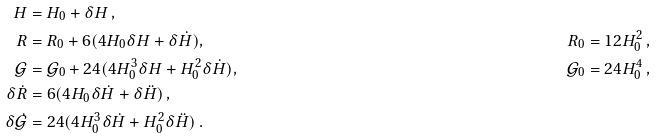Convert formula to latex. <formula><loc_0><loc_0><loc_500><loc_500>H & = H _ { 0 } + \delta H \, , & \\ R & = R _ { 0 } + 6 ( 4 H _ { 0 } \delta H + \delta \dot { H } ) , & R _ { 0 } = 1 2 H _ { 0 } ^ { 2 } \, , \\ \mathcal { G } & = \mathcal { G } _ { 0 } + 2 4 ( 4 H _ { 0 } ^ { 3 } \delta H + H _ { 0 } ^ { 2 } \delta \dot { H } ) , & \mathcal { G } _ { 0 } = 2 4 H _ { 0 } ^ { 4 } \, , \\ \delta \dot { R } & = 6 ( 4 H _ { 0 } \delta \dot { H } + \delta \ddot { H } ) \, , & \\ \delta \dot { \mathcal { G } } & = 2 4 ( 4 H _ { 0 } ^ { 3 } \delta { \dot { H } } + H _ { 0 } ^ { 2 } \delta { \ddot { H } } ) \, . &</formula> 